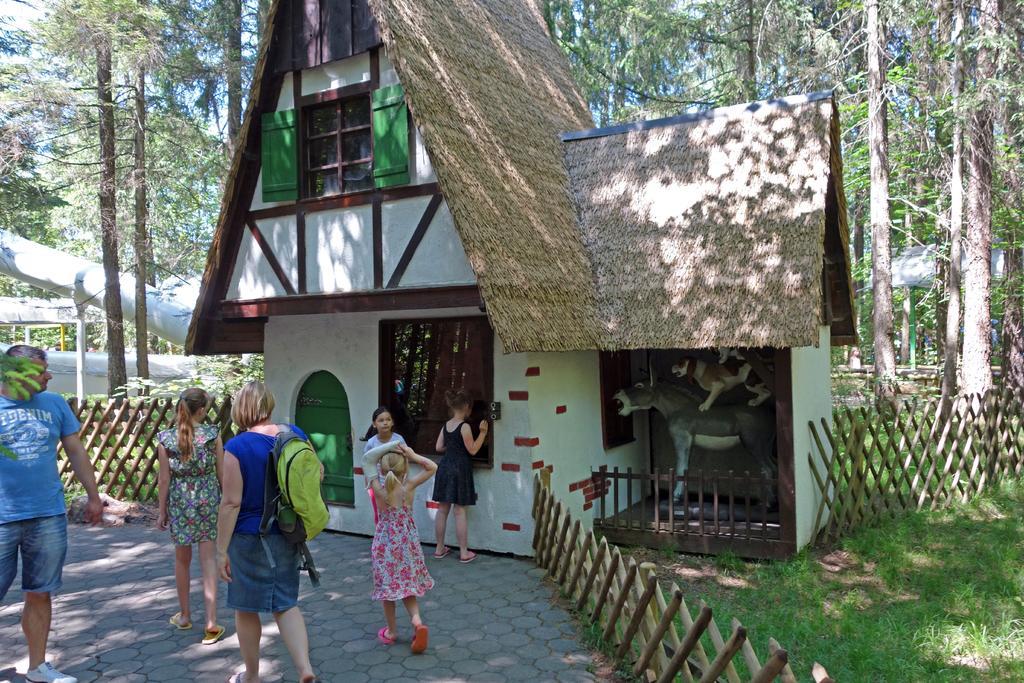Please provide a concise description of this image. In this picture we can see people on the ground, here we can see a fence, house, statue of animals and in the background we can see trees, shed, skye and some objects. 